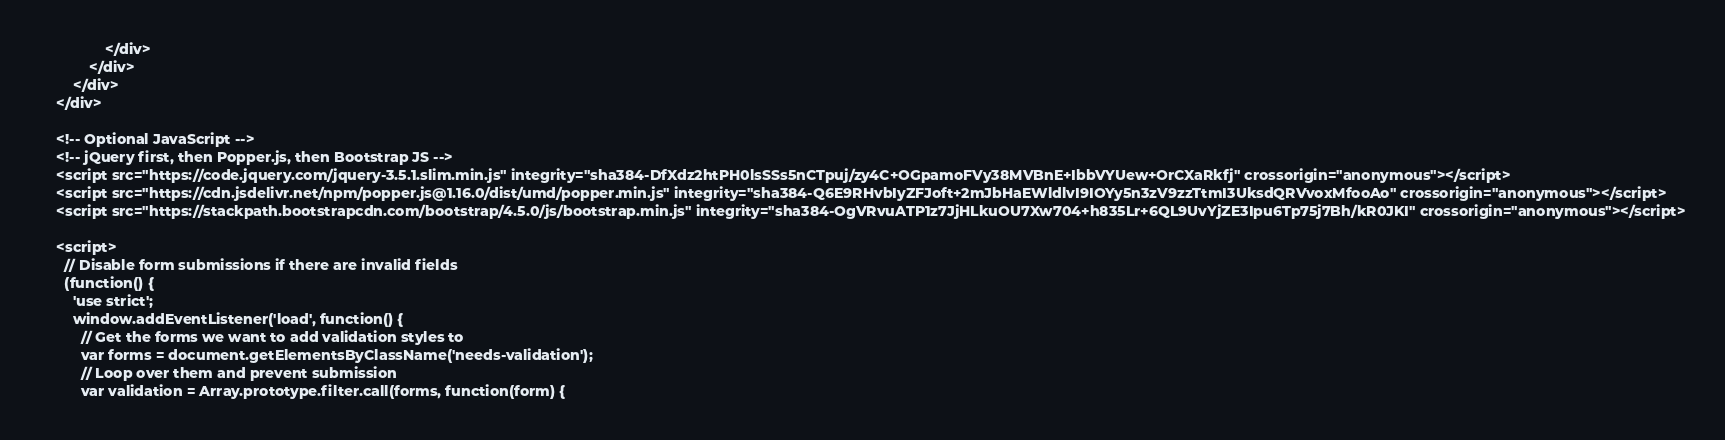Convert code to text. <code><loc_0><loc_0><loc_500><loc_500><_PHP_>                </div>
            </div>
        </div>
    </div>

    <!-- Optional JavaScript -->
    <!-- jQuery first, then Popper.js, then Bootstrap JS -->
    <script src="https://code.jquery.com/jquery-3.5.1.slim.min.js" integrity="sha384-DfXdz2htPH0lsSSs5nCTpuj/zy4C+OGpamoFVy38MVBnE+IbbVYUew+OrCXaRkfj" crossorigin="anonymous"></script>
    <script src="https://cdn.jsdelivr.net/npm/popper.js@1.16.0/dist/umd/popper.min.js" integrity="sha384-Q6E9RHvbIyZFJoft+2mJbHaEWldlvI9IOYy5n3zV9zzTtmI3UksdQRVvoxMfooAo" crossorigin="anonymous"></script>
    <script src="https://stackpath.bootstrapcdn.com/bootstrap/4.5.0/js/bootstrap.min.js" integrity="sha384-OgVRvuATP1z7JjHLkuOU7Xw704+h835Lr+6QL9UvYjZE3Ipu6Tp75j7Bh/kR0JKI" crossorigin="anonymous"></script>

    <script>
      // Disable form submissions if there are invalid fields
      (function() {
        'use strict';
        window.addEventListener('load', function() {
          // Get the forms we want to add validation styles to
          var forms = document.getElementsByClassName('needs-validation');
          // Loop over them and prevent submission
          var validation = Array.prototype.filter.call(forms, function(form) {</code> 